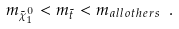<formula> <loc_0><loc_0><loc_500><loc_500>m _ { \tilde { \chi } ^ { 0 } _ { 1 } } < m _ { \tilde { t } } < m _ { a l l o t h e r s } \ .</formula> 